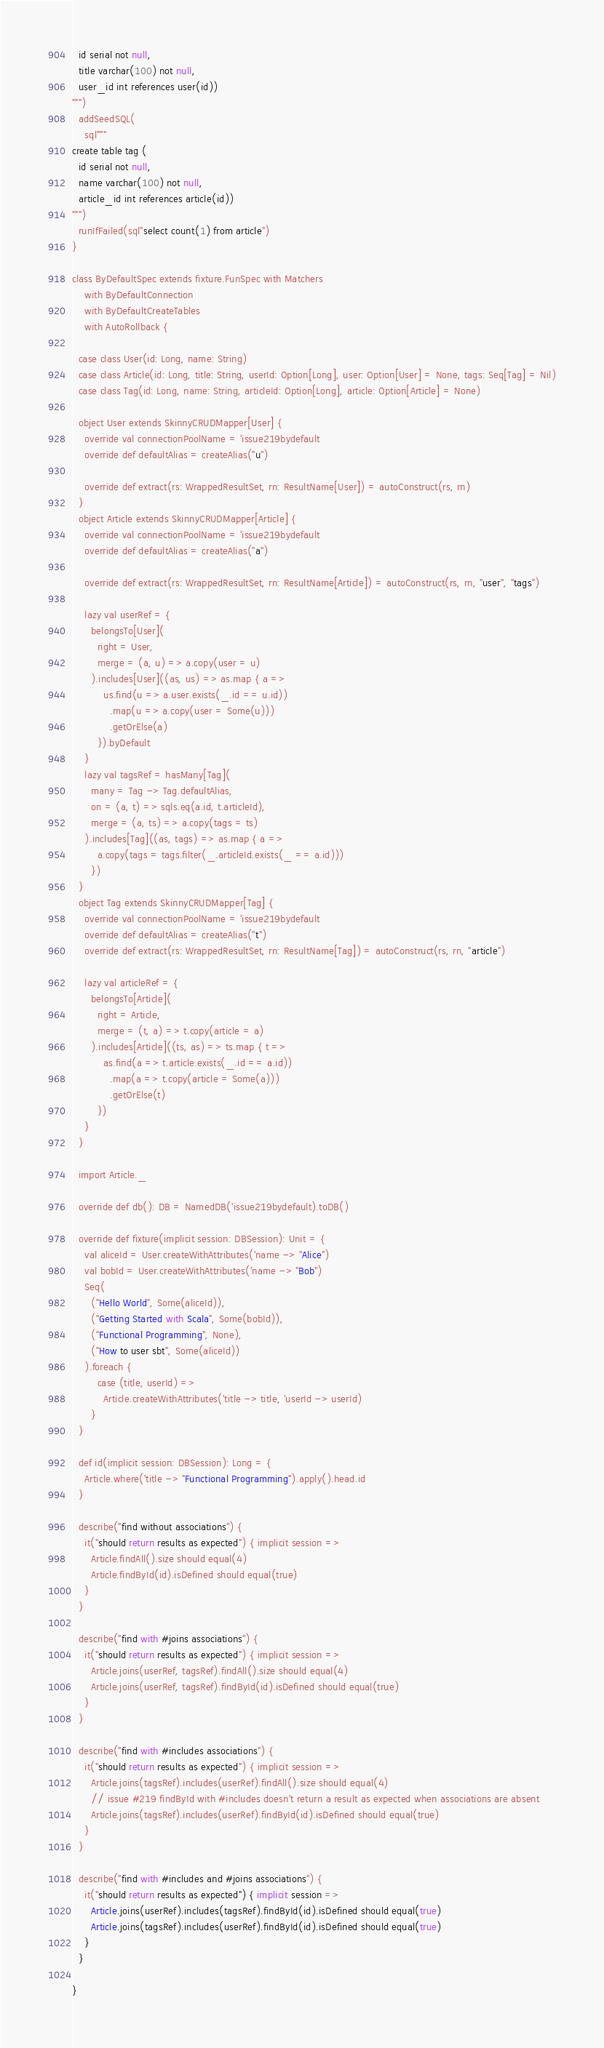Convert code to text. <code><loc_0><loc_0><loc_500><loc_500><_Scala_>  id serial not null,
  title varchar(100) not null,
  user_id int references user(id))
""")
  addSeedSQL(
    sql"""
create table tag (
  id serial not null,
  name varchar(100) not null,
  article_id int references article(id))
""")
  runIfFailed(sql"select count(1) from article")
}

class ByDefaultSpec extends fixture.FunSpec with Matchers
    with ByDefaultConnection
    with ByDefaultCreateTables
    with AutoRollback {

  case class User(id: Long, name: String)
  case class Article(id: Long, title: String, userId: Option[Long], user: Option[User] = None, tags: Seq[Tag] = Nil)
  case class Tag(id: Long, name: String, articleId: Option[Long], article: Option[Article] = None)

  object User extends SkinnyCRUDMapper[User] {
    override val connectionPoolName = 'issue219bydefault
    override def defaultAlias = createAlias("u")

    override def extract(rs: WrappedResultSet, rn: ResultName[User]) = autoConstruct(rs, rn)
  }
  object Article extends SkinnyCRUDMapper[Article] {
    override val connectionPoolName = 'issue219bydefault
    override def defaultAlias = createAlias("a")

    override def extract(rs: WrappedResultSet, rn: ResultName[Article]) = autoConstruct(rs, rn, "user", "tags")

    lazy val userRef = {
      belongsTo[User](
        right = User,
        merge = (a, u) => a.copy(user = u)
      ).includes[User]((as, us) => as.map { a =>
          us.find(u => a.user.exists(_.id == u.id))
            .map(u => a.copy(user = Some(u)))
            .getOrElse(a)
        }).byDefault
    }
    lazy val tagsRef = hasMany[Tag](
      many = Tag -> Tag.defaultAlias,
      on = (a, t) => sqls.eq(a.id, t.articleId),
      merge = (a, ts) => a.copy(tags = ts)
    ).includes[Tag]((as, tags) => as.map { a =>
        a.copy(tags = tags.filter(_.articleId.exists(_ == a.id)))
      })
  }
  object Tag extends SkinnyCRUDMapper[Tag] {
    override val connectionPoolName = 'issue219bydefault
    override def defaultAlias = createAlias("t")
    override def extract(rs: WrappedResultSet, rn: ResultName[Tag]) = autoConstruct(rs, rn, "article")

    lazy val articleRef = {
      belongsTo[Article](
        right = Article,
        merge = (t, a) => t.copy(article = a)
      ).includes[Article]((ts, as) => ts.map { t =>
          as.find(a => t.article.exists(_.id == a.id))
            .map(a => t.copy(article = Some(a)))
            .getOrElse(t)
        })
    }
  }

  import Article._

  override def db(): DB = NamedDB('issue219bydefault).toDB()

  override def fixture(implicit session: DBSession): Unit = {
    val aliceId = User.createWithAttributes('name -> "Alice")
    val bobId = User.createWithAttributes('name -> "Bob")
    Seq(
      ("Hello World", Some(aliceId)),
      ("Getting Started with Scala", Some(bobId)),
      ("Functional Programming", None),
      ("How to user sbt", Some(aliceId))
    ).foreach {
        case (title, userId) =>
          Article.createWithAttributes('title -> title, 'userId -> userId)
      }
  }

  def id(implicit session: DBSession): Long = {
    Article.where('title -> "Functional Programming").apply().head.id
  }

  describe("find without associations") {
    it("should return results as expected") { implicit session =>
      Article.findAll().size should equal(4)
      Article.findById(id).isDefined should equal(true)
    }
  }

  describe("find with #joins associations") {
    it("should return results as expected") { implicit session =>
      Article.joins(userRef, tagsRef).findAll().size should equal(4)
      Article.joins(userRef, tagsRef).findById(id).isDefined should equal(true)
    }
  }

  describe("find with #includes associations") {
    it("should return results as expected") { implicit session =>
      Article.joins(tagsRef).includes(userRef).findAll().size should equal(4)
      // issue #219 findById with #includes doesn't return a result as expected when associations are absent
      Article.joins(tagsRef).includes(userRef).findById(id).isDefined should equal(true)
    }
  }

  describe("find with #includes and #joins associations") {
    it("should return results as expected") { implicit session =>
      Article.joins(userRef).includes(tagsRef).findById(id).isDefined should equal(true)
      Article.joins(tagsRef).includes(userRef).findById(id).isDefined should equal(true)
    }
  }

}
</code> 